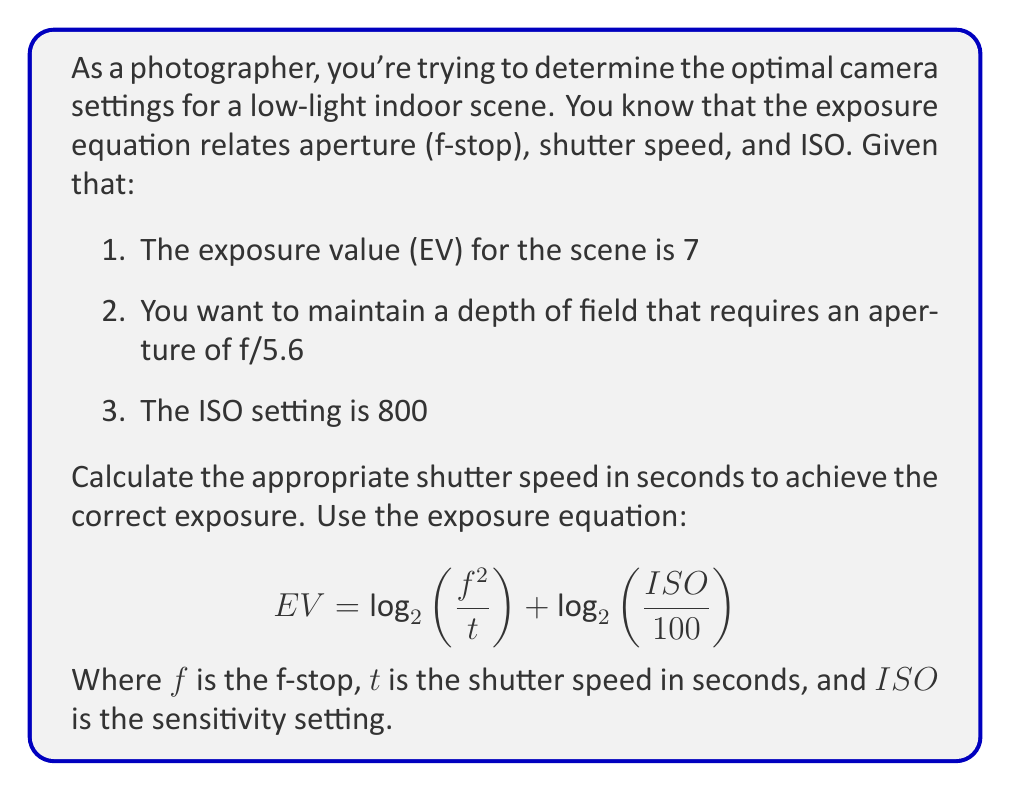Can you answer this question? Let's approach this step-by-step:

1) We're given the exposure equation:
   $$EV = \log_2\left(\frac{f^2}{t}\right) + \log_2\left(\frac{ISO}{100}\right)$$

2) We know:
   - $EV = 7$
   - $f = 5.6$
   - $ISO = 800$

3) Let's substitute these values into the equation:
   $$7 = \log_2\left(\frac{5.6^2}{t}\right) + \log_2\left(\frac{800}{100}\right)$$

4) Simplify the second logarithm:
   $$7 = \log_2\left(\frac{5.6^2}{t}\right) + \log_2(8) = \log_2\left(\frac{5.6^2}{t}\right) + 3$$

5) Subtract 3 from both sides:
   $$4 = \log_2\left(\frac{5.6^2}{t}\right)$$

6) Apply $2^x$ to both sides:
   $$2^4 = \frac{5.6^2}{t}$$

7) Simplify:
   $$16 = \frac{31.36}{t}$$

8) Multiply both sides by $t$:
   $$16t = 31.36$$

9) Divide both sides by 16:
   $$t = \frac{31.36}{16} = 1.96$$

Therefore, the shutter speed should be 1.96 seconds.
Answer: The optimal shutter speed is 1.96 seconds. 